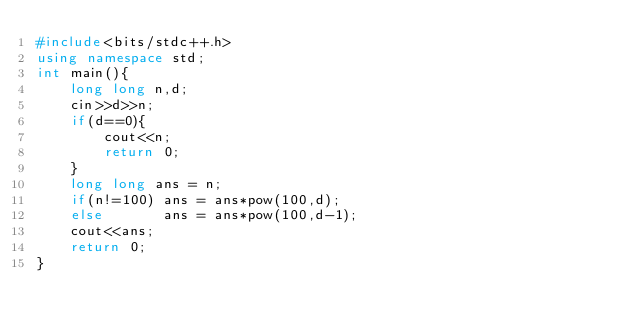<code> <loc_0><loc_0><loc_500><loc_500><_C++_>#include<bits/stdc++.h>
using namespace std;
int main(){
    long long n,d;
    cin>>d>>n;
    if(d==0){
        cout<<n;
        return 0;
    }
    long long ans = n;
    if(n!=100) ans = ans*pow(100,d);
    else       ans = ans*pow(100,d-1);
    cout<<ans;
    return 0;
}</code> 